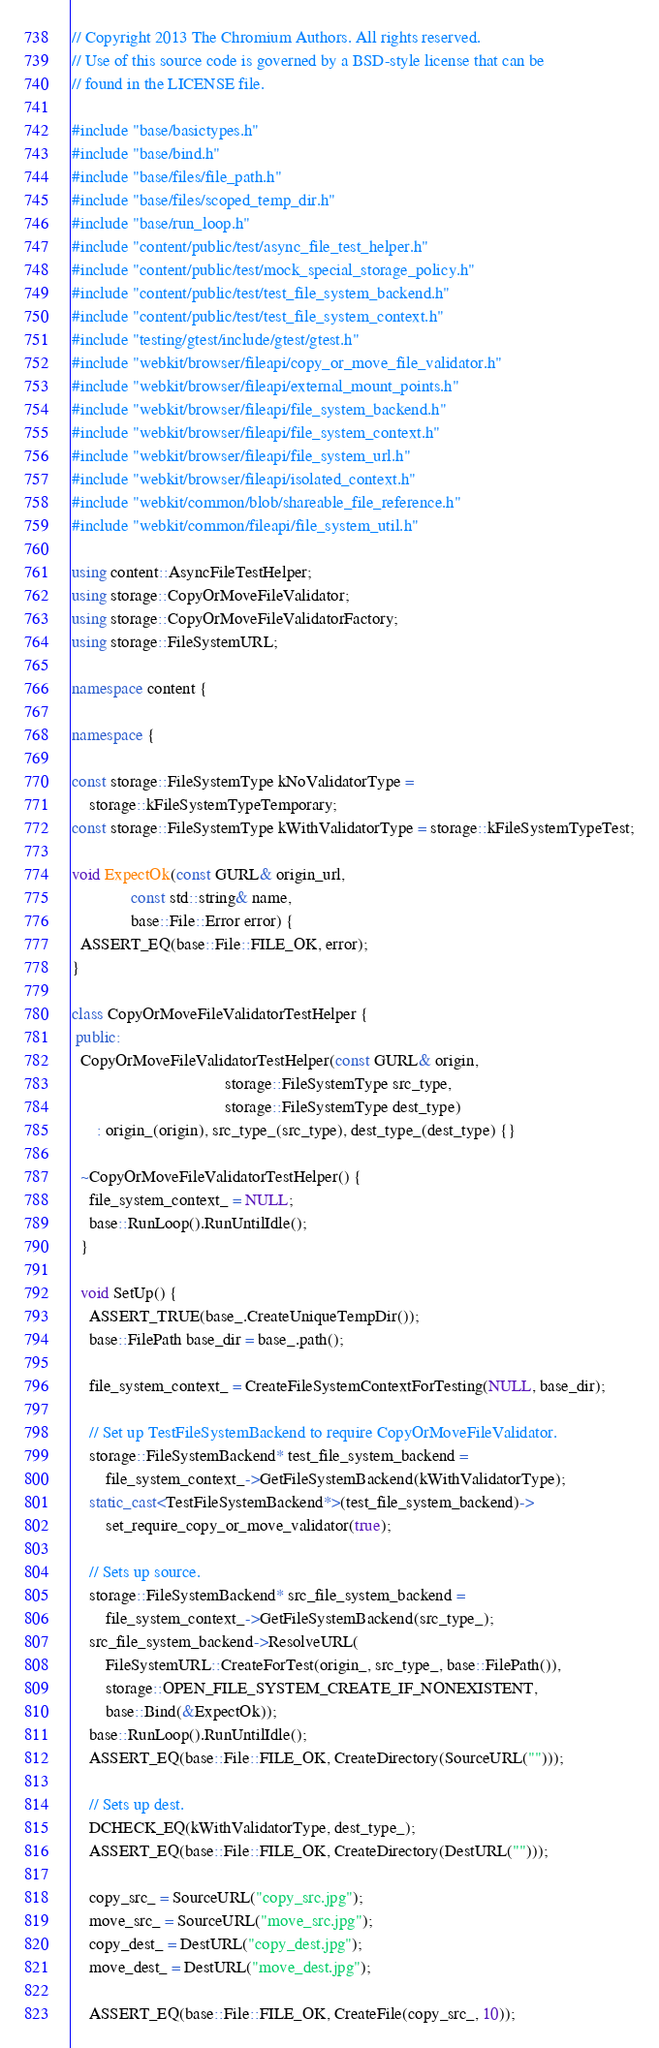Convert code to text. <code><loc_0><loc_0><loc_500><loc_500><_C++_>// Copyright 2013 The Chromium Authors. All rights reserved.
// Use of this source code is governed by a BSD-style license that can be
// found in the LICENSE file.

#include "base/basictypes.h"
#include "base/bind.h"
#include "base/files/file_path.h"
#include "base/files/scoped_temp_dir.h"
#include "base/run_loop.h"
#include "content/public/test/async_file_test_helper.h"
#include "content/public/test/mock_special_storage_policy.h"
#include "content/public/test/test_file_system_backend.h"
#include "content/public/test/test_file_system_context.h"
#include "testing/gtest/include/gtest/gtest.h"
#include "webkit/browser/fileapi/copy_or_move_file_validator.h"
#include "webkit/browser/fileapi/external_mount_points.h"
#include "webkit/browser/fileapi/file_system_backend.h"
#include "webkit/browser/fileapi/file_system_context.h"
#include "webkit/browser/fileapi/file_system_url.h"
#include "webkit/browser/fileapi/isolated_context.h"
#include "webkit/common/blob/shareable_file_reference.h"
#include "webkit/common/fileapi/file_system_util.h"

using content::AsyncFileTestHelper;
using storage::CopyOrMoveFileValidator;
using storage::CopyOrMoveFileValidatorFactory;
using storage::FileSystemURL;

namespace content {

namespace {

const storage::FileSystemType kNoValidatorType =
    storage::kFileSystemTypeTemporary;
const storage::FileSystemType kWithValidatorType = storage::kFileSystemTypeTest;

void ExpectOk(const GURL& origin_url,
              const std::string& name,
              base::File::Error error) {
  ASSERT_EQ(base::File::FILE_OK, error);
}

class CopyOrMoveFileValidatorTestHelper {
 public:
  CopyOrMoveFileValidatorTestHelper(const GURL& origin,
                                    storage::FileSystemType src_type,
                                    storage::FileSystemType dest_type)
      : origin_(origin), src_type_(src_type), dest_type_(dest_type) {}

  ~CopyOrMoveFileValidatorTestHelper() {
    file_system_context_ = NULL;
    base::RunLoop().RunUntilIdle();
  }

  void SetUp() {
    ASSERT_TRUE(base_.CreateUniqueTempDir());
    base::FilePath base_dir = base_.path();

    file_system_context_ = CreateFileSystemContextForTesting(NULL, base_dir);

    // Set up TestFileSystemBackend to require CopyOrMoveFileValidator.
    storage::FileSystemBackend* test_file_system_backend =
        file_system_context_->GetFileSystemBackend(kWithValidatorType);
    static_cast<TestFileSystemBackend*>(test_file_system_backend)->
        set_require_copy_or_move_validator(true);

    // Sets up source.
    storage::FileSystemBackend* src_file_system_backend =
        file_system_context_->GetFileSystemBackend(src_type_);
    src_file_system_backend->ResolveURL(
        FileSystemURL::CreateForTest(origin_, src_type_, base::FilePath()),
        storage::OPEN_FILE_SYSTEM_CREATE_IF_NONEXISTENT,
        base::Bind(&ExpectOk));
    base::RunLoop().RunUntilIdle();
    ASSERT_EQ(base::File::FILE_OK, CreateDirectory(SourceURL("")));

    // Sets up dest.
    DCHECK_EQ(kWithValidatorType, dest_type_);
    ASSERT_EQ(base::File::FILE_OK, CreateDirectory(DestURL("")));

    copy_src_ = SourceURL("copy_src.jpg");
    move_src_ = SourceURL("move_src.jpg");
    copy_dest_ = DestURL("copy_dest.jpg");
    move_dest_ = DestURL("move_dest.jpg");

    ASSERT_EQ(base::File::FILE_OK, CreateFile(copy_src_, 10));</code> 